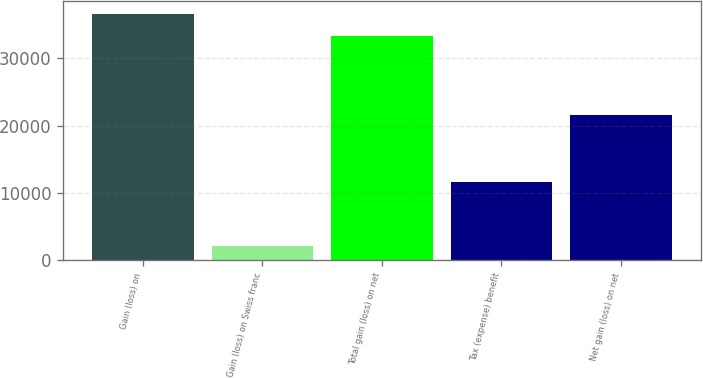Convert chart. <chart><loc_0><loc_0><loc_500><loc_500><bar_chart><fcel>Gain (loss) on<fcel>Gain (loss) on Swiss franc<fcel>Total gain (loss) on net<fcel>Tax (expense) benefit<fcel>Net gain (loss) on net<nl><fcel>36600.3<fcel>2185<fcel>33273<fcel>11646<fcel>21627<nl></chart> 